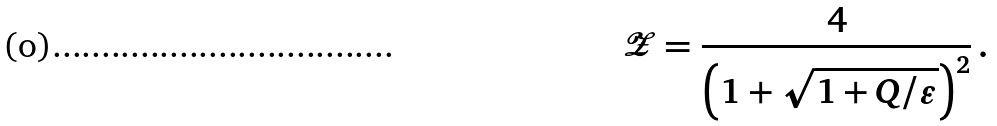Convert formula to latex. <formula><loc_0><loc_0><loc_500><loc_500>\mathcal { Z } = \frac { 4 } { \left ( 1 + \sqrt { 1 + Q / \varepsilon } \right ) ^ { 2 } } \, .</formula> 